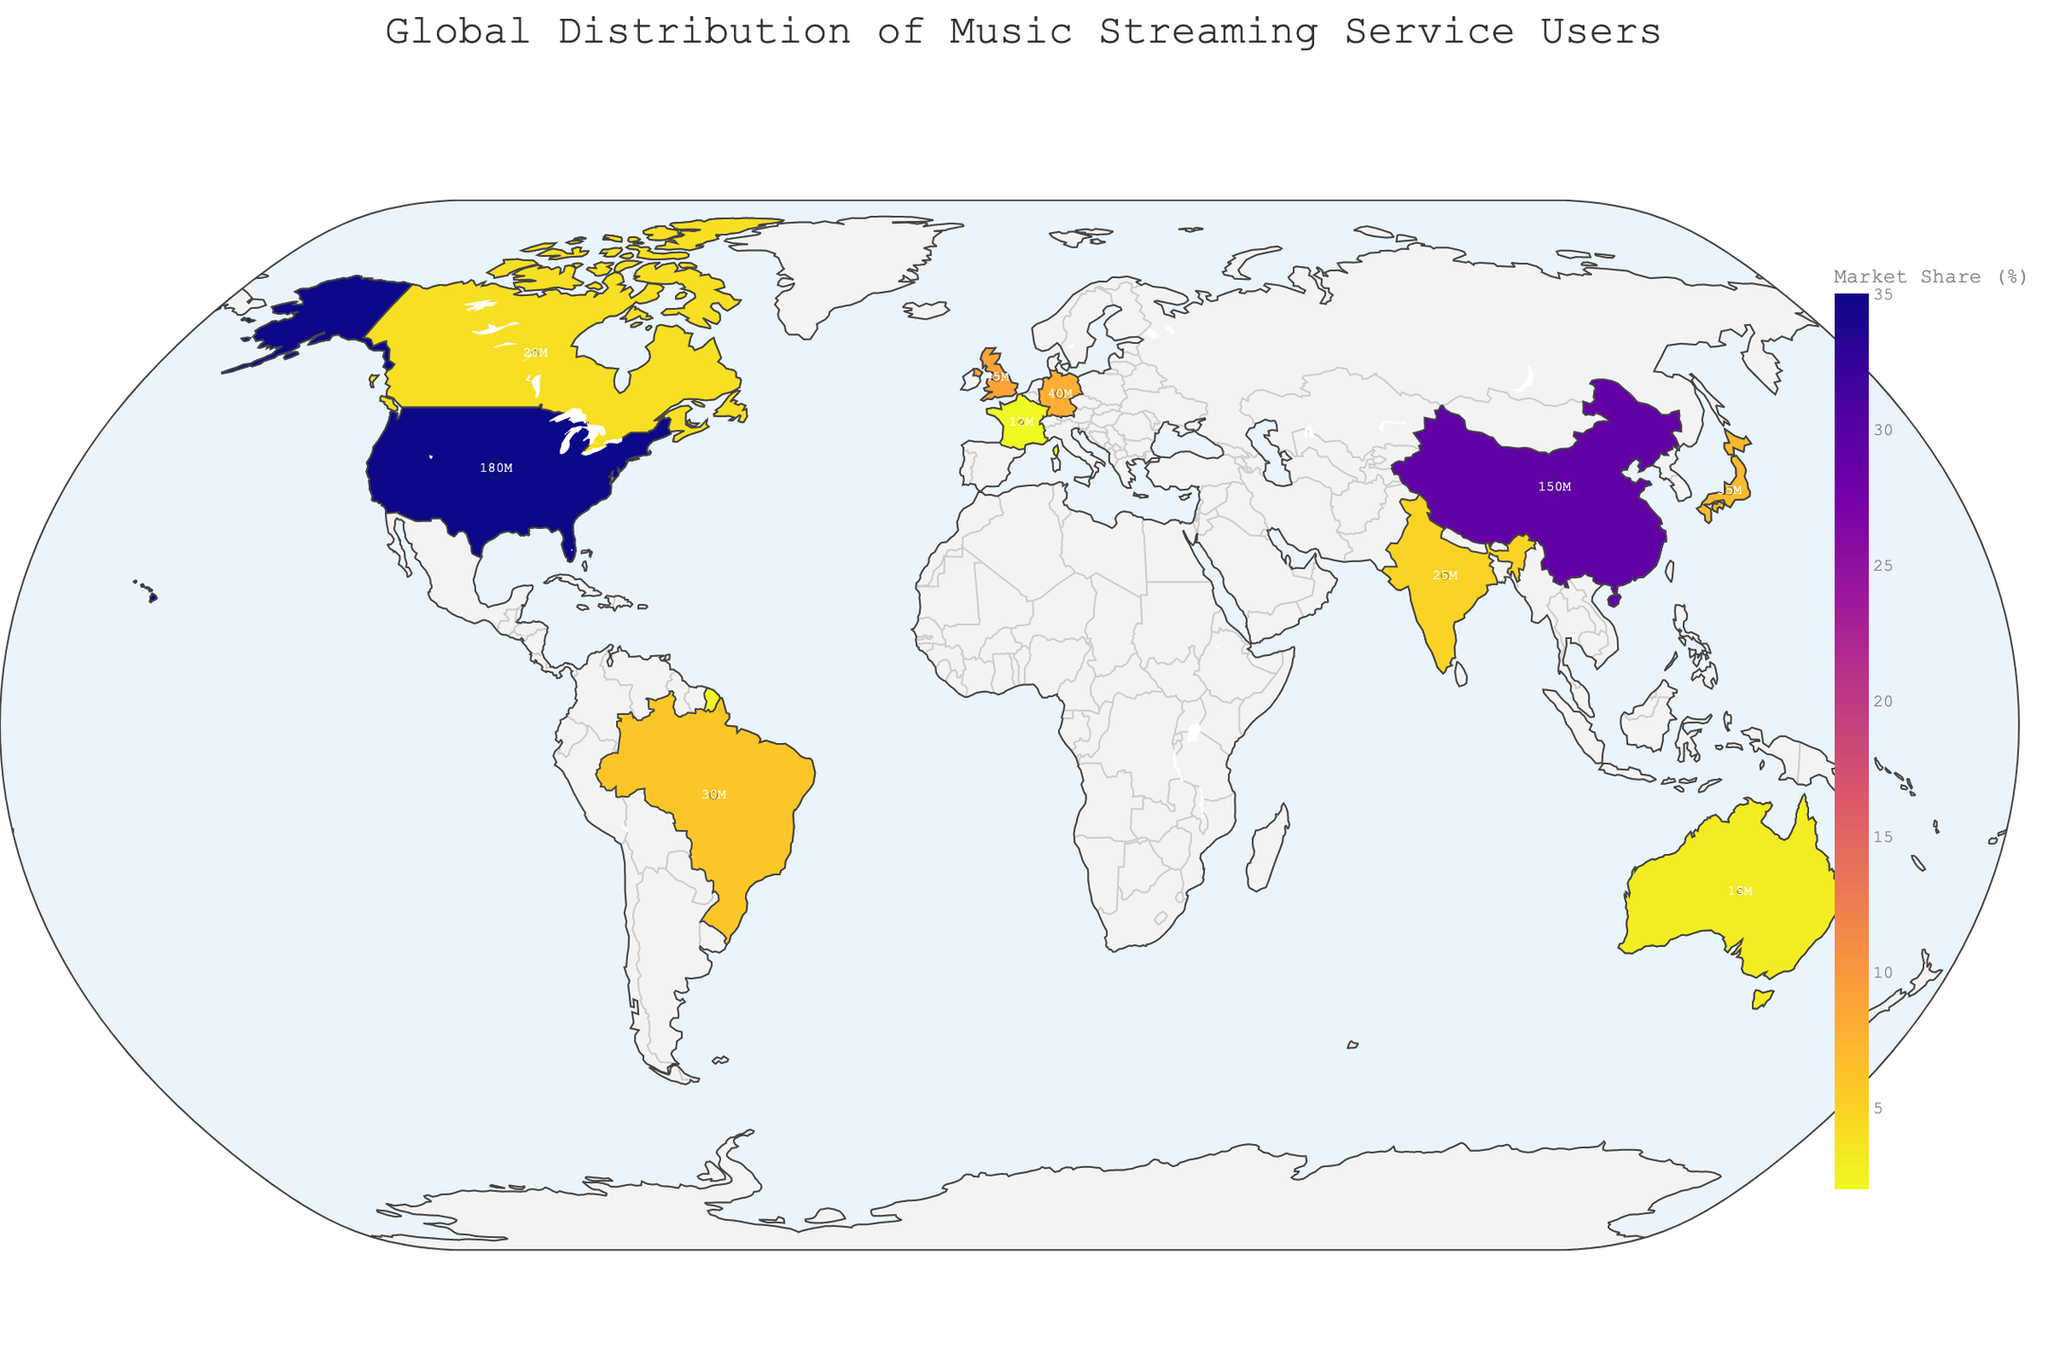What's the title of the figure? The title is usually placed at the top center of the figure, describing the main theme. For this figure, it reads "Global Distribution of Music Streaming Service Users".
Answer: Global Distribution of Music Streaming Service Users Which country has the highest number of music streaming users? You can identify this by looking at the hover data or bubble sizes; the United States has 180 million users, which is the highest.
Answer: United States What colors are used to represent the market share in the figure? According to the color scale, the figure uses a sequential color palette ranging from light to dark shades, visualized in different levels of purple to gold.
Answer: Purple to Gold What is the market share percentage of Canada? By hovering over Canada, the hover data shows its market share percentage is 4%.
Answer: 4% How does the number of users in China compare to those in the United Kingdom? China has 150 million users while the United Kingdom has 45 million users. Subtracting these, we get 150 - 45 = 105 million more users in China.
Answer: 105 million more users Which country has the lowest number of users and what is the top local artist there? By looking at the hover data, France has the lowest number of users with 12 million, and the top local artist is Daft Punk.
Answer: France, Daft Punk What is the combined market share of the countries with less than 10 million users? All countries shown have more than 10 million users. Thus, no need to calculate a combined market share for less than 10 million users.
Answer: No countries with less than 10 million users Which continent appears to have the largest total market share percentage across its countries? Comparing market shares across continents, North America (United States and Canada) together total 39%, which is highest among all continents.
Answer: North America What is the average number of users for the European countries listed in the figure? The European countries in the figure are the United Kingdom (45 million), Germany (40 million), and France (12 million). The average is calculated as (45 + 40 + 12) / 3 = 32.33 million users.
Answer: 32.33 million users What local artists are highlighted in the figure for Asian countries? The top local artists for Asian countries in the figure are Jay Chou (China), BABYMETAL (Japan), and A.R. Rahman (India).
Answer: Jay Chou, BABYMETAL, A.R. Rahman 